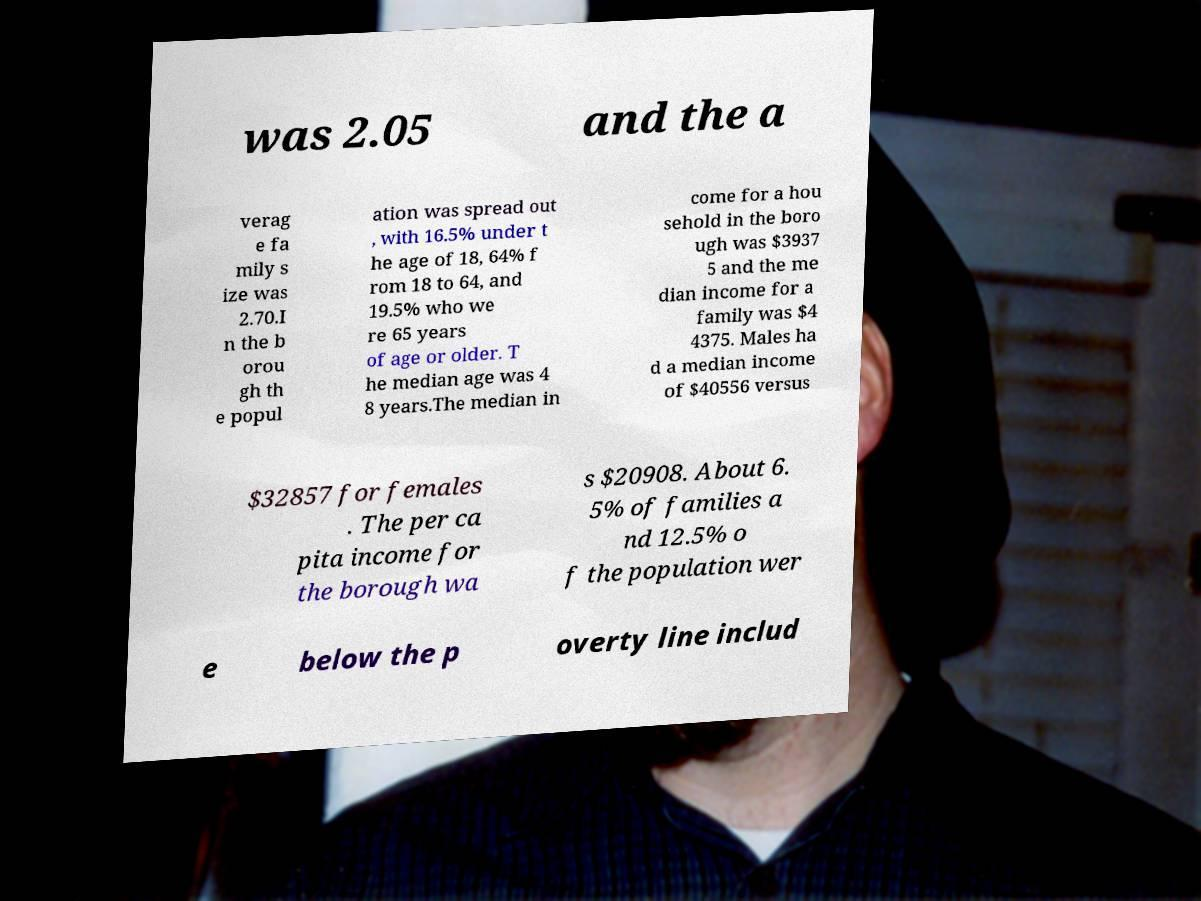Can you read and provide the text displayed in the image?This photo seems to have some interesting text. Can you extract and type it out for me? was 2.05 and the a verag e fa mily s ize was 2.70.I n the b orou gh th e popul ation was spread out , with 16.5% under t he age of 18, 64% f rom 18 to 64, and 19.5% who we re 65 years of age or older. T he median age was 4 8 years.The median in come for a hou sehold in the boro ugh was $3937 5 and the me dian income for a family was $4 4375. Males ha d a median income of $40556 versus $32857 for females . The per ca pita income for the borough wa s $20908. About 6. 5% of families a nd 12.5% o f the population wer e below the p overty line includ 